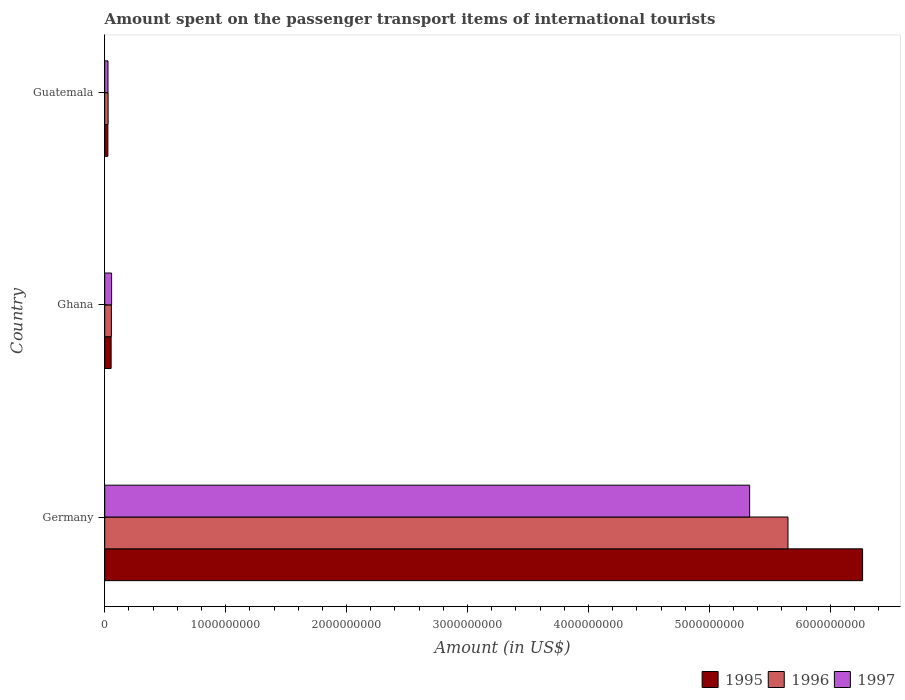How many different coloured bars are there?
Offer a terse response. 3. Are the number of bars per tick equal to the number of legend labels?
Provide a short and direct response. Yes. How many bars are there on the 2nd tick from the top?
Ensure brevity in your answer.  3. What is the label of the 1st group of bars from the top?
Provide a short and direct response. Guatemala. In how many cases, is the number of bars for a given country not equal to the number of legend labels?
Ensure brevity in your answer.  0. What is the amount spent on the passenger transport items of international tourists in 1996 in Guatemala?
Your response must be concise. 2.80e+07. Across all countries, what is the maximum amount spent on the passenger transport items of international tourists in 1995?
Your answer should be very brief. 6.27e+09. Across all countries, what is the minimum amount spent on the passenger transport items of international tourists in 1995?
Ensure brevity in your answer.  2.60e+07. In which country was the amount spent on the passenger transport items of international tourists in 1996 maximum?
Offer a terse response. Germany. In which country was the amount spent on the passenger transport items of international tourists in 1995 minimum?
Your answer should be compact. Guatemala. What is the total amount spent on the passenger transport items of international tourists in 1996 in the graph?
Your answer should be compact. 5.73e+09. What is the difference between the amount spent on the passenger transport items of international tourists in 1995 in Germany and that in Guatemala?
Keep it short and to the point. 6.24e+09. What is the difference between the amount spent on the passenger transport items of international tourists in 1995 in Ghana and the amount spent on the passenger transport items of international tourists in 1997 in Germany?
Provide a succinct answer. -5.28e+09. What is the average amount spent on the passenger transport items of international tourists in 1995 per country?
Your answer should be very brief. 2.12e+09. What is the difference between the amount spent on the passenger transport items of international tourists in 1997 and amount spent on the passenger transport items of international tourists in 1995 in Ghana?
Offer a very short reply. 4.00e+06. What is the ratio of the amount spent on the passenger transport items of international tourists in 1997 in Ghana to that in Guatemala?
Offer a terse response. 2.11. Is the amount spent on the passenger transport items of international tourists in 1997 in Ghana less than that in Guatemala?
Give a very brief answer. No. Is the difference between the amount spent on the passenger transport items of international tourists in 1997 in Ghana and Guatemala greater than the difference between the amount spent on the passenger transport items of international tourists in 1995 in Ghana and Guatemala?
Ensure brevity in your answer.  Yes. What is the difference between the highest and the second highest amount spent on the passenger transport items of international tourists in 1995?
Your answer should be very brief. 6.21e+09. What is the difference between the highest and the lowest amount spent on the passenger transport items of international tourists in 1997?
Provide a succinct answer. 5.31e+09. In how many countries, is the amount spent on the passenger transport items of international tourists in 1997 greater than the average amount spent on the passenger transport items of international tourists in 1997 taken over all countries?
Ensure brevity in your answer.  1. What does the 3rd bar from the bottom in Guatemala represents?
Your answer should be compact. 1997. Is it the case that in every country, the sum of the amount spent on the passenger transport items of international tourists in 1996 and amount spent on the passenger transport items of international tourists in 1995 is greater than the amount spent on the passenger transport items of international tourists in 1997?
Provide a short and direct response. Yes. How many bars are there?
Offer a terse response. 9. Are all the bars in the graph horizontal?
Ensure brevity in your answer.  Yes. Does the graph contain any zero values?
Offer a very short reply. No. Does the graph contain grids?
Provide a succinct answer. No. Where does the legend appear in the graph?
Your response must be concise. Bottom right. What is the title of the graph?
Provide a short and direct response. Amount spent on the passenger transport items of international tourists. Does "1972" appear as one of the legend labels in the graph?
Provide a short and direct response. No. What is the label or title of the X-axis?
Provide a succinct answer. Amount (in US$). What is the label or title of the Y-axis?
Give a very brief answer. Country. What is the Amount (in US$) in 1995 in Germany?
Your answer should be very brief. 6.27e+09. What is the Amount (in US$) in 1996 in Germany?
Offer a very short reply. 5.65e+09. What is the Amount (in US$) of 1997 in Germany?
Make the answer very short. 5.33e+09. What is the Amount (in US$) in 1995 in Ghana?
Provide a succinct answer. 5.30e+07. What is the Amount (in US$) of 1996 in Ghana?
Give a very brief answer. 5.50e+07. What is the Amount (in US$) of 1997 in Ghana?
Your answer should be compact. 5.70e+07. What is the Amount (in US$) in 1995 in Guatemala?
Your answer should be compact. 2.60e+07. What is the Amount (in US$) of 1996 in Guatemala?
Provide a short and direct response. 2.80e+07. What is the Amount (in US$) in 1997 in Guatemala?
Offer a very short reply. 2.70e+07. Across all countries, what is the maximum Amount (in US$) in 1995?
Your answer should be very brief. 6.27e+09. Across all countries, what is the maximum Amount (in US$) of 1996?
Your answer should be very brief. 5.65e+09. Across all countries, what is the maximum Amount (in US$) of 1997?
Provide a short and direct response. 5.33e+09. Across all countries, what is the minimum Amount (in US$) in 1995?
Your response must be concise. 2.60e+07. Across all countries, what is the minimum Amount (in US$) in 1996?
Offer a terse response. 2.80e+07. Across all countries, what is the minimum Amount (in US$) in 1997?
Give a very brief answer. 2.70e+07. What is the total Amount (in US$) in 1995 in the graph?
Your response must be concise. 6.35e+09. What is the total Amount (in US$) in 1996 in the graph?
Offer a terse response. 5.73e+09. What is the total Amount (in US$) of 1997 in the graph?
Offer a very short reply. 5.42e+09. What is the difference between the Amount (in US$) in 1995 in Germany and that in Ghana?
Keep it short and to the point. 6.21e+09. What is the difference between the Amount (in US$) in 1996 in Germany and that in Ghana?
Your answer should be very brief. 5.60e+09. What is the difference between the Amount (in US$) of 1997 in Germany and that in Ghana?
Make the answer very short. 5.28e+09. What is the difference between the Amount (in US$) of 1995 in Germany and that in Guatemala?
Your answer should be very brief. 6.24e+09. What is the difference between the Amount (in US$) in 1996 in Germany and that in Guatemala?
Offer a terse response. 5.62e+09. What is the difference between the Amount (in US$) in 1997 in Germany and that in Guatemala?
Make the answer very short. 5.31e+09. What is the difference between the Amount (in US$) of 1995 in Ghana and that in Guatemala?
Offer a terse response. 2.70e+07. What is the difference between the Amount (in US$) in 1996 in Ghana and that in Guatemala?
Ensure brevity in your answer.  2.70e+07. What is the difference between the Amount (in US$) of 1997 in Ghana and that in Guatemala?
Offer a very short reply. 3.00e+07. What is the difference between the Amount (in US$) in 1995 in Germany and the Amount (in US$) in 1996 in Ghana?
Your answer should be very brief. 6.21e+09. What is the difference between the Amount (in US$) in 1995 in Germany and the Amount (in US$) in 1997 in Ghana?
Make the answer very short. 6.21e+09. What is the difference between the Amount (in US$) in 1996 in Germany and the Amount (in US$) in 1997 in Ghana?
Your answer should be very brief. 5.59e+09. What is the difference between the Amount (in US$) of 1995 in Germany and the Amount (in US$) of 1996 in Guatemala?
Provide a short and direct response. 6.24e+09. What is the difference between the Amount (in US$) of 1995 in Germany and the Amount (in US$) of 1997 in Guatemala?
Ensure brevity in your answer.  6.24e+09. What is the difference between the Amount (in US$) of 1996 in Germany and the Amount (in US$) of 1997 in Guatemala?
Your answer should be compact. 5.62e+09. What is the difference between the Amount (in US$) of 1995 in Ghana and the Amount (in US$) of 1996 in Guatemala?
Your response must be concise. 2.50e+07. What is the difference between the Amount (in US$) of 1995 in Ghana and the Amount (in US$) of 1997 in Guatemala?
Ensure brevity in your answer.  2.60e+07. What is the difference between the Amount (in US$) in 1996 in Ghana and the Amount (in US$) in 1997 in Guatemala?
Keep it short and to the point. 2.80e+07. What is the average Amount (in US$) of 1995 per country?
Give a very brief answer. 2.12e+09. What is the average Amount (in US$) in 1996 per country?
Keep it short and to the point. 1.91e+09. What is the average Amount (in US$) of 1997 per country?
Offer a very short reply. 1.81e+09. What is the difference between the Amount (in US$) of 1995 and Amount (in US$) of 1996 in Germany?
Keep it short and to the point. 6.17e+08. What is the difference between the Amount (in US$) in 1995 and Amount (in US$) in 1997 in Germany?
Keep it short and to the point. 9.34e+08. What is the difference between the Amount (in US$) of 1996 and Amount (in US$) of 1997 in Germany?
Your response must be concise. 3.17e+08. What is the difference between the Amount (in US$) in 1995 and Amount (in US$) in 1996 in Guatemala?
Provide a succinct answer. -2.00e+06. What is the difference between the Amount (in US$) of 1995 and Amount (in US$) of 1997 in Guatemala?
Provide a succinct answer. -1.00e+06. What is the difference between the Amount (in US$) of 1996 and Amount (in US$) of 1997 in Guatemala?
Offer a very short reply. 1.00e+06. What is the ratio of the Amount (in US$) of 1995 in Germany to that in Ghana?
Provide a short and direct response. 118.25. What is the ratio of the Amount (in US$) in 1996 in Germany to that in Ghana?
Your answer should be compact. 102.73. What is the ratio of the Amount (in US$) of 1997 in Germany to that in Ghana?
Ensure brevity in your answer.  93.56. What is the ratio of the Amount (in US$) of 1995 in Germany to that in Guatemala?
Give a very brief answer. 241.04. What is the ratio of the Amount (in US$) of 1996 in Germany to that in Guatemala?
Give a very brief answer. 201.79. What is the ratio of the Amount (in US$) in 1997 in Germany to that in Guatemala?
Offer a very short reply. 197.52. What is the ratio of the Amount (in US$) in 1995 in Ghana to that in Guatemala?
Keep it short and to the point. 2.04. What is the ratio of the Amount (in US$) of 1996 in Ghana to that in Guatemala?
Offer a very short reply. 1.96. What is the ratio of the Amount (in US$) of 1997 in Ghana to that in Guatemala?
Your answer should be compact. 2.11. What is the difference between the highest and the second highest Amount (in US$) of 1995?
Offer a terse response. 6.21e+09. What is the difference between the highest and the second highest Amount (in US$) in 1996?
Make the answer very short. 5.60e+09. What is the difference between the highest and the second highest Amount (in US$) of 1997?
Provide a succinct answer. 5.28e+09. What is the difference between the highest and the lowest Amount (in US$) of 1995?
Give a very brief answer. 6.24e+09. What is the difference between the highest and the lowest Amount (in US$) of 1996?
Your response must be concise. 5.62e+09. What is the difference between the highest and the lowest Amount (in US$) in 1997?
Your answer should be compact. 5.31e+09. 